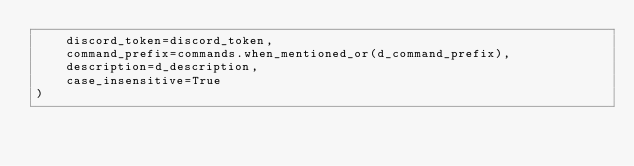Convert code to text. <code><loc_0><loc_0><loc_500><loc_500><_Python_>    discord_token=discord_token,
    command_prefix=commands.when_mentioned_or(d_command_prefix),
    description=d_description,
    case_insensitive=True
)
</code> 